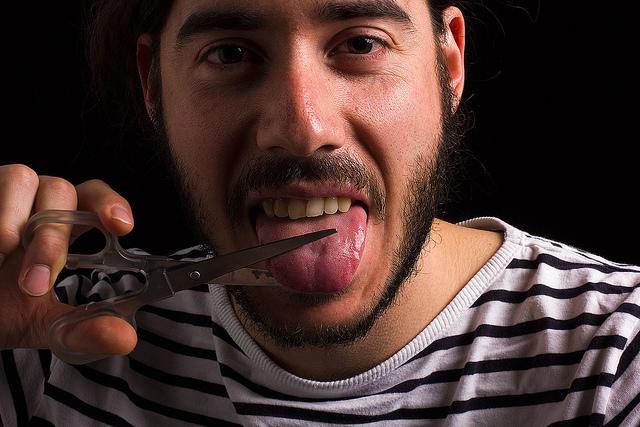Is the man going to cut himself?
Give a very brief answer. No. What color is the man's hair?
Give a very brief answer. Black. What pattern is his shirt?
Quick response, please. Striped. 